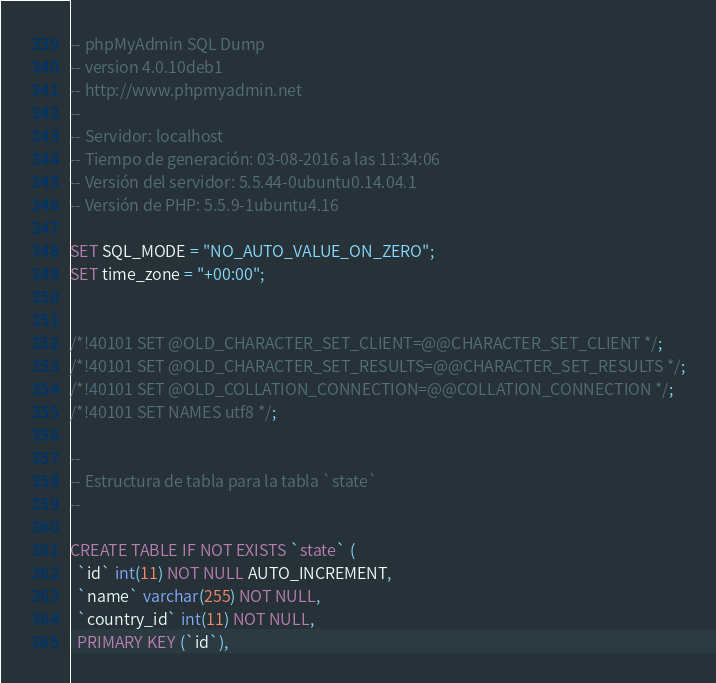Convert code to text. <code><loc_0><loc_0><loc_500><loc_500><_SQL_>-- phpMyAdmin SQL Dump
-- version 4.0.10deb1
-- http://www.phpmyadmin.net
--
-- Servidor: localhost
-- Tiempo de generación: 03-08-2016 a las 11:34:06
-- Versión del servidor: 5.5.44-0ubuntu0.14.04.1
-- Versión de PHP: 5.5.9-1ubuntu4.16

SET SQL_MODE = "NO_AUTO_VALUE_ON_ZERO";
SET time_zone = "+00:00";


/*!40101 SET @OLD_CHARACTER_SET_CLIENT=@@CHARACTER_SET_CLIENT */;
/*!40101 SET @OLD_CHARACTER_SET_RESULTS=@@CHARACTER_SET_RESULTS */;
/*!40101 SET @OLD_COLLATION_CONNECTION=@@COLLATION_CONNECTION */;
/*!40101 SET NAMES utf8 */;

--
-- Estructura de tabla para la tabla `state`
--

CREATE TABLE IF NOT EXISTS `state` (
  `id` int(11) NOT NULL AUTO_INCREMENT,
  `name` varchar(255) NOT NULL,
  `country_id` int(11) NOT NULL,
  PRIMARY KEY (`id`),</code> 